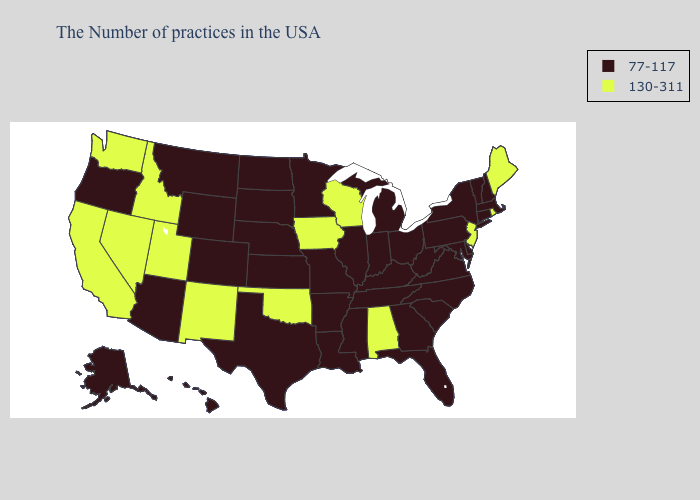What is the value of New York?
Write a very short answer. 77-117. What is the highest value in states that border Alabama?
Write a very short answer. 77-117. What is the value of Nebraska?
Keep it brief. 77-117. Does Minnesota have the highest value in the MidWest?
Keep it brief. No. What is the highest value in the USA?
Answer briefly. 130-311. Name the states that have a value in the range 130-311?
Short answer required. Maine, Rhode Island, New Jersey, Alabama, Wisconsin, Iowa, Oklahoma, New Mexico, Utah, Idaho, Nevada, California, Washington. What is the value of California?
Keep it brief. 130-311. Does Wisconsin have the highest value in the MidWest?
Keep it brief. Yes. Name the states that have a value in the range 77-117?
Answer briefly. Massachusetts, New Hampshire, Vermont, Connecticut, New York, Delaware, Maryland, Pennsylvania, Virginia, North Carolina, South Carolina, West Virginia, Ohio, Florida, Georgia, Michigan, Kentucky, Indiana, Tennessee, Illinois, Mississippi, Louisiana, Missouri, Arkansas, Minnesota, Kansas, Nebraska, Texas, South Dakota, North Dakota, Wyoming, Colorado, Montana, Arizona, Oregon, Alaska, Hawaii. Does Oklahoma have the lowest value in the South?
Quick response, please. No. Does Iowa have the lowest value in the MidWest?
Quick response, please. No. Name the states that have a value in the range 77-117?
Keep it brief. Massachusetts, New Hampshire, Vermont, Connecticut, New York, Delaware, Maryland, Pennsylvania, Virginia, North Carolina, South Carolina, West Virginia, Ohio, Florida, Georgia, Michigan, Kentucky, Indiana, Tennessee, Illinois, Mississippi, Louisiana, Missouri, Arkansas, Minnesota, Kansas, Nebraska, Texas, South Dakota, North Dakota, Wyoming, Colorado, Montana, Arizona, Oregon, Alaska, Hawaii. What is the value of North Carolina?
Concise answer only. 77-117. Among the states that border New Mexico , does Arizona have the highest value?
Quick response, please. No. Does the map have missing data?
Give a very brief answer. No. 